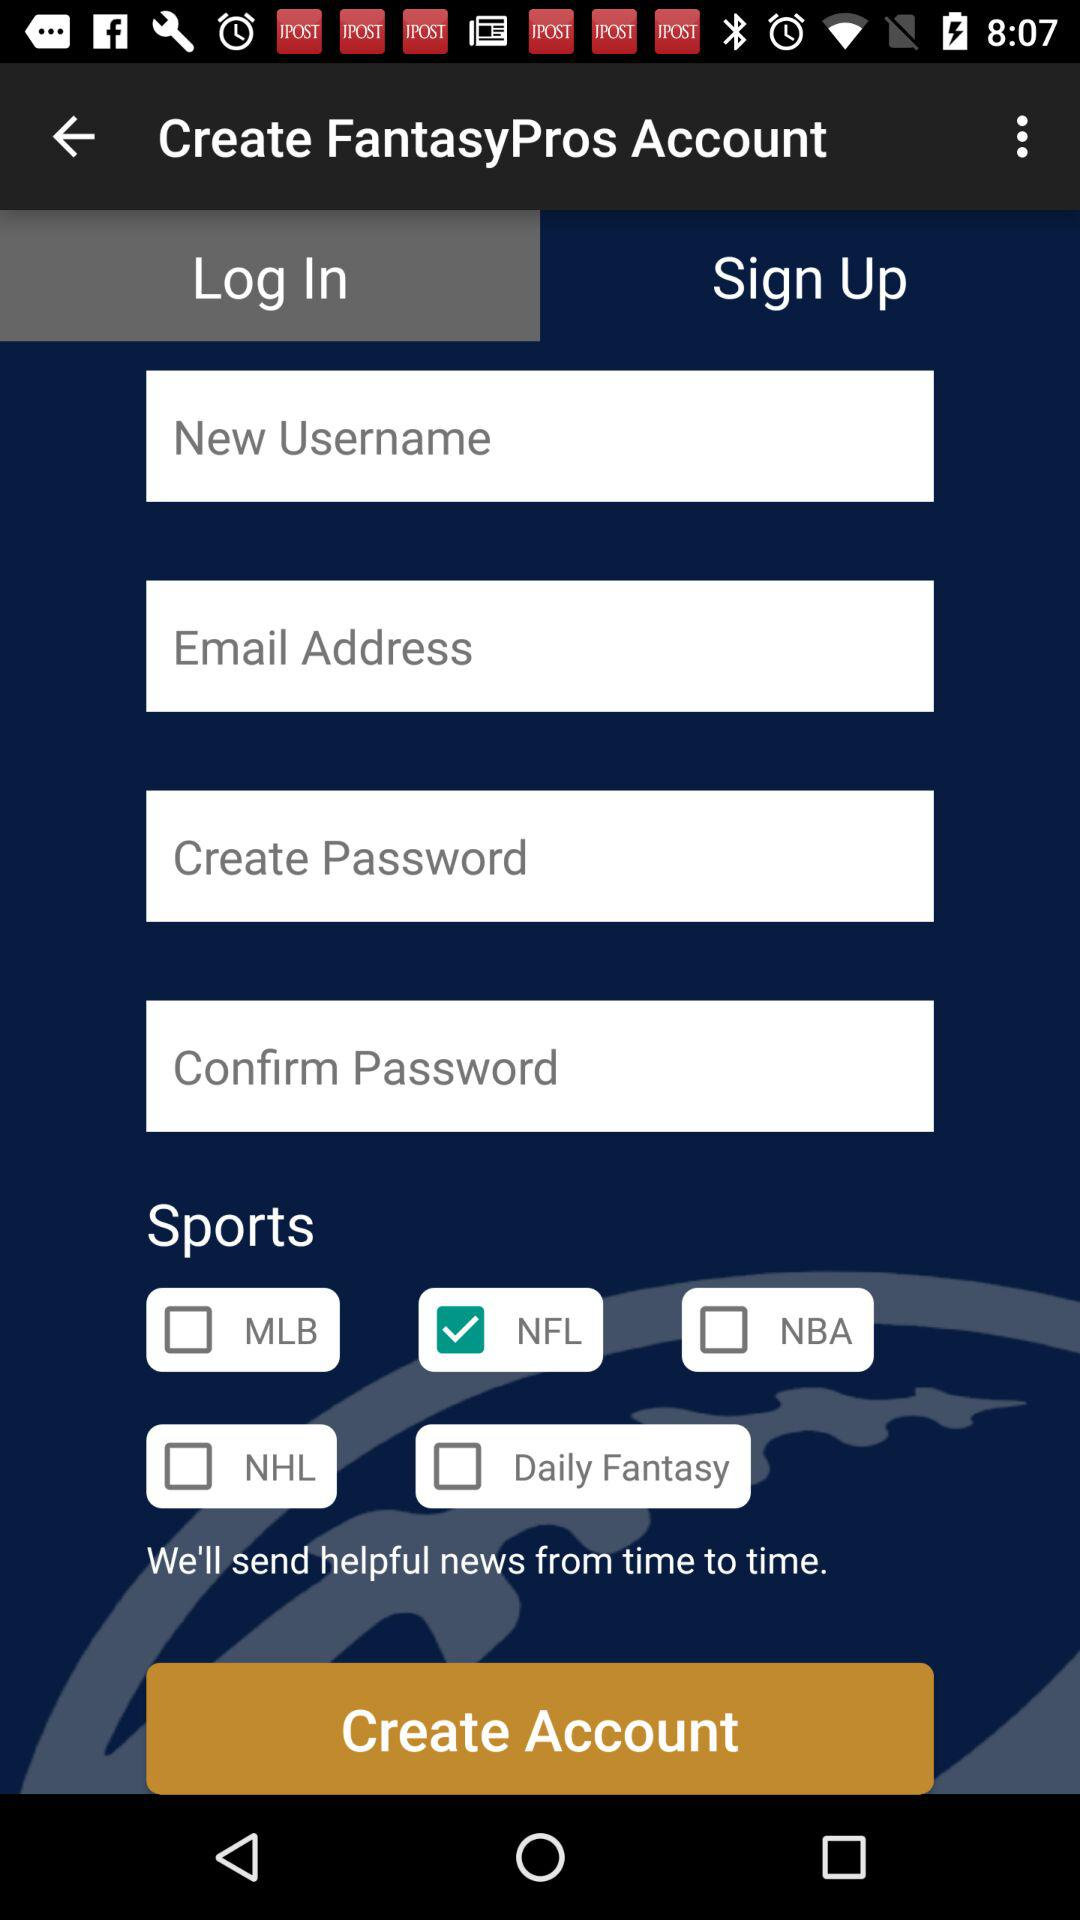Which sports option has been selected? The sports option that has been selected is "NFL". 